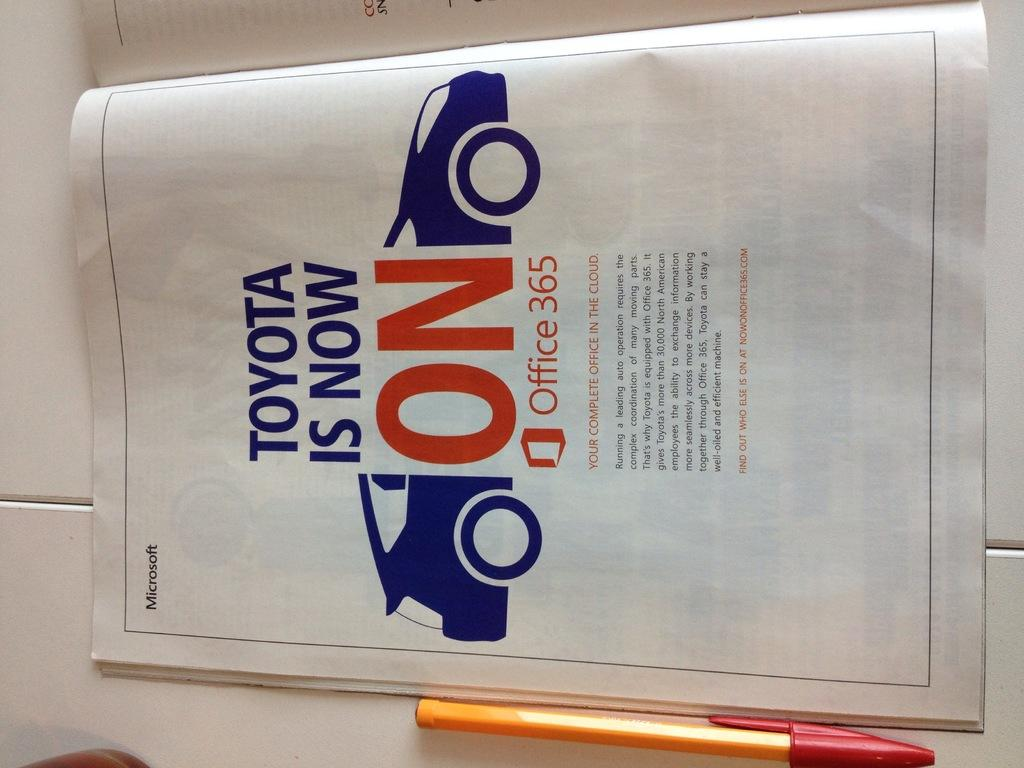<image>
Create a compact narrative representing the image presented. An ad from a magazine saying that Toyota is on Office 365. 